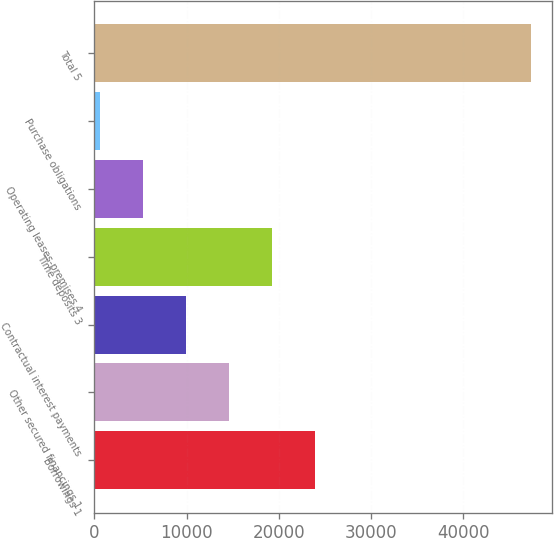<chart> <loc_0><loc_0><loc_500><loc_500><bar_chart><fcel>Borrowings 1<fcel>Other secured financings 1<fcel>Contractual interest payments<fcel>Time deposits 3<fcel>Operating leases-premises 4<fcel>Purchase obligations<fcel>Total 5<nl><fcel>23962.5<fcel>14616.7<fcel>9943.8<fcel>19289.6<fcel>5270.9<fcel>598<fcel>47327<nl></chart> 